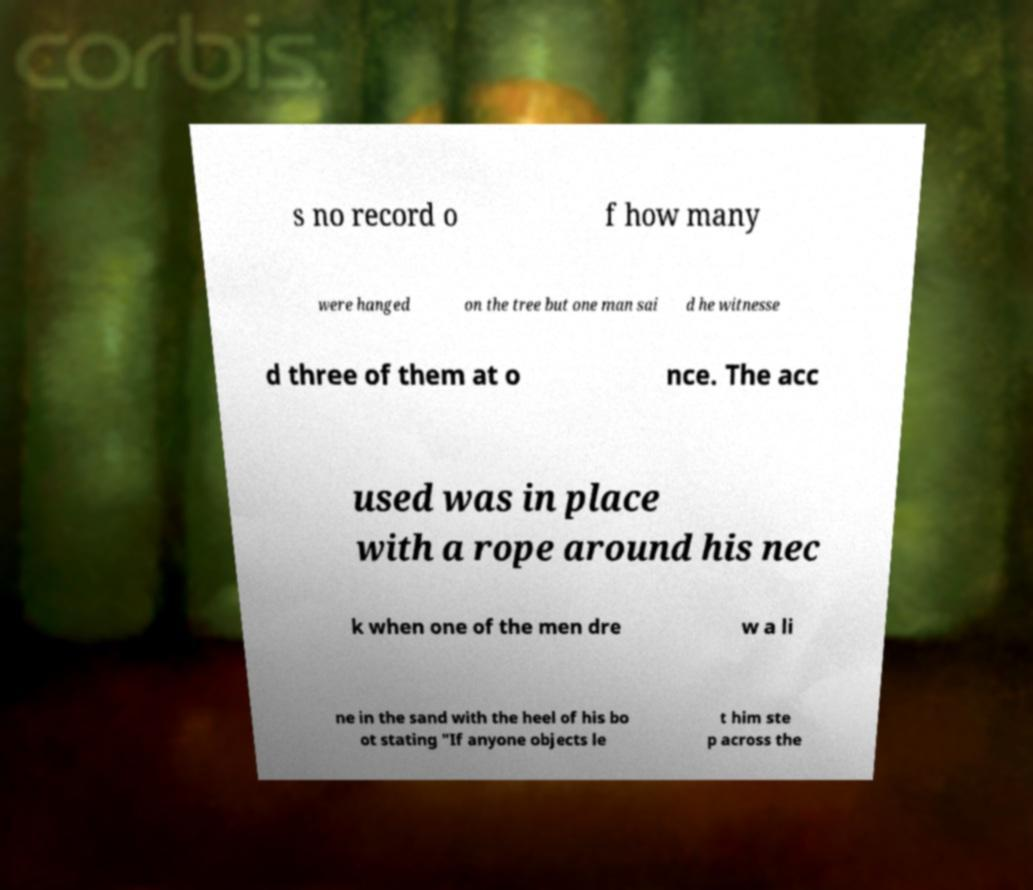There's text embedded in this image that I need extracted. Can you transcribe it verbatim? s no record o f how many were hanged on the tree but one man sai d he witnesse d three of them at o nce. The acc used was in place with a rope around his nec k when one of the men dre w a li ne in the sand with the heel of his bo ot stating "If anyone objects le t him ste p across the 